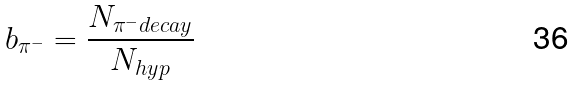Convert formula to latex. <formula><loc_0><loc_0><loc_500><loc_500>b _ { \pi ^ { - } } = \frac { N _ { \pi ^ { - } d e c a y } } { N _ { h y p } }</formula> 